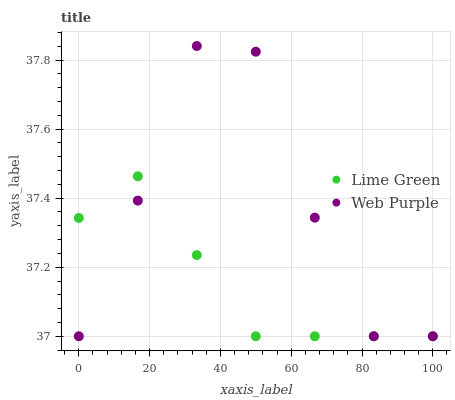Does Lime Green have the minimum area under the curve?
Answer yes or no. Yes. Does Web Purple have the maximum area under the curve?
Answer yes or no. Yes. Does Lime Green have the maximum area under the curve?
Answer yes or no. No. Is Lime Green the smoothest?
Answer yes or no. Yes. Is Web Purple the roughest?
Answer yes or no. Yes. Is Lime Green the roughest?
Answer yes or no. No. Does Web Purple have the lowest value?
Answer yes or no. Yes. Does Web Purple have the highest value?
Answer yes or no. Yes. Does Lime Green have the highest value?
Answer yes or no. No. Does Lime Green intersect Web Purple?
Answer yes or no. Yes. Is Lime Green less than Web Purple?
Answer yes or no. No. Is Lime Green greater than Web Purple?
Answer yes or no. No. 